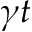Convert formula to latex. <formula><loc_0><loc_0><loc_500><loc_500>\gamma t</formula> 